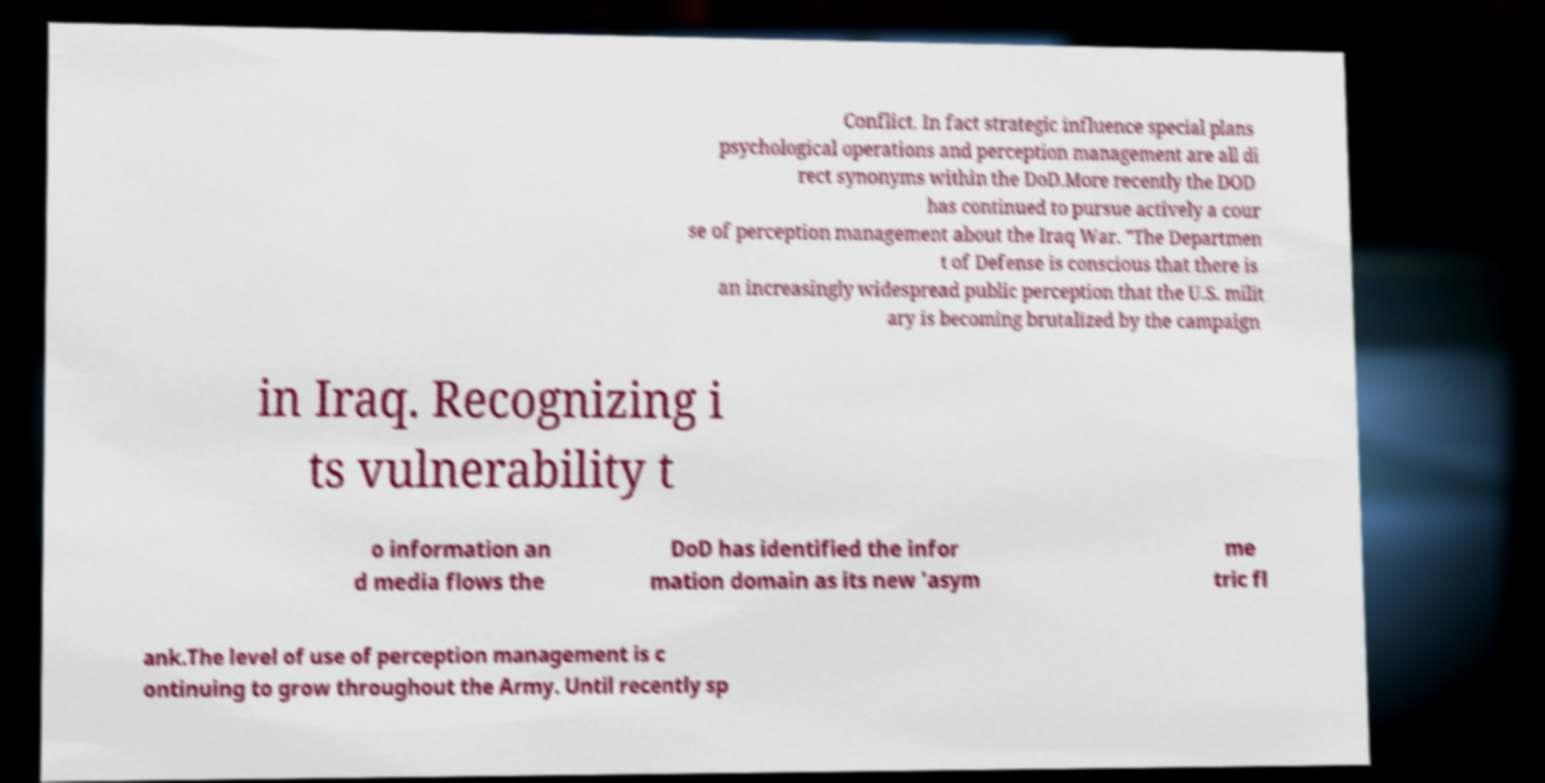I need the written content from this picture converted into text. Can you do that? Conflict. In fact strategic influence special plans psychological operations and perception management are all di rect synonyms within the DoD.More recently the DOD has continued to pursue actively a cour se of perception management about the Iraq War. "The Departmen t of Defense is conscious that there is an increasingly widespread public perception that the U.S. milit ary is becoming brutalized by the campaign in Iraq. Recognizing i ts vulnerability t o information an d media flows the DoD has identified the infor mation domain as its new 'asym me tric fl ank.The level of use of perception management is c ontinuing to grow throughout the Army. Until recently sp 